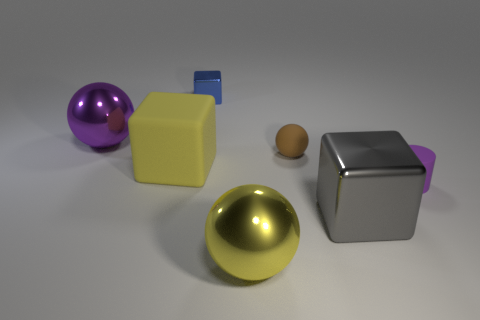What number of purple objects are either large things or cylinders?
Offer a very short reply. 2. Are there any purple things behind the big cube that is on the left side of the block that is behind the matte ball?
Provide a short and direct response. Yes. What shape is the large object that is the same color as the cylinder?
Your response must be concise. Sphere. How many big things are metal objects or purple cylinders?
Make the answer very short. 3. There is a big yellow object behind the big gray metallic thing; is its shape the same as the big gray shiny object?
Ensure brevity in your answer.  Yes. Is the number of large rubber objects less than the number of yellow rubber cylinders?
Your answer should be compact. No. Is there any other thing of the same color as the large matte thing?
Keep it short and to the point. Yes. There is a big yellow object that is left of the blue thing; what shape is it?
Ensure brevity in your answer.  Cube. There is a big rubber cube; is its color the same as the big ball in front of the small brown rubber thing?
Offer a very short reply. Yes. Are there an equal number of big shiny objects that are left of the tiny purple cylinder and cubes in front of the gray thing?
Offer a terse response. No. 